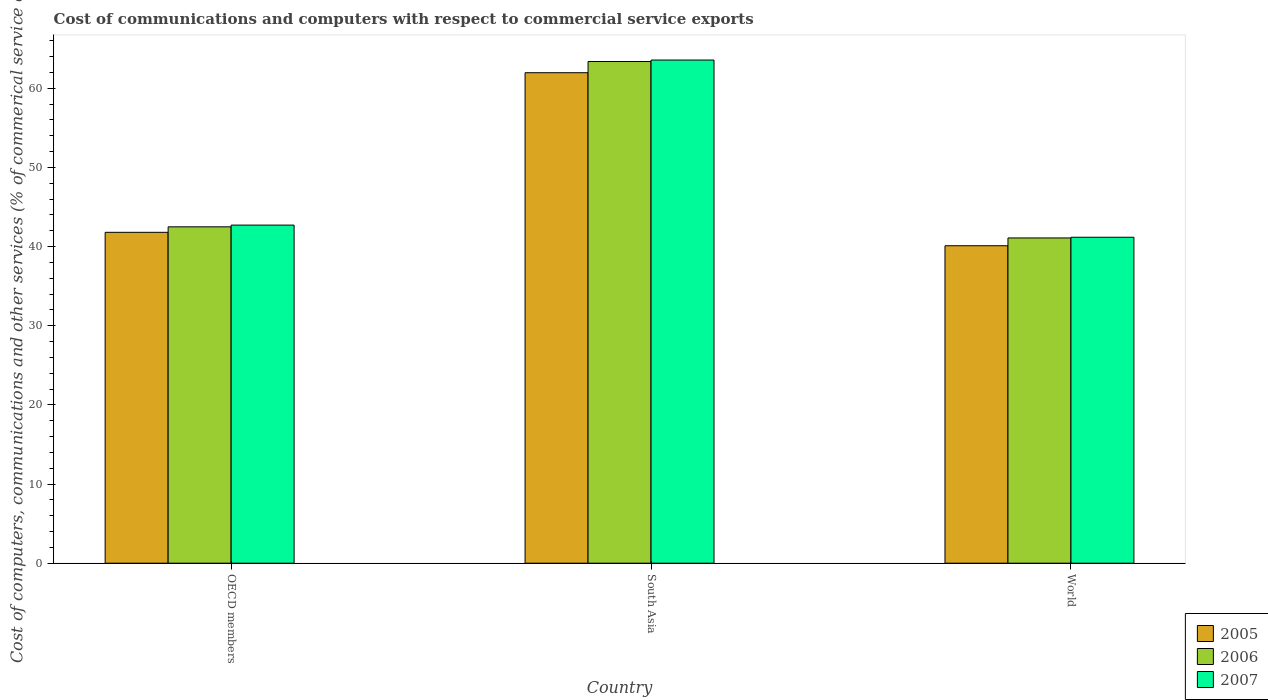How many different coloured bars are there?
Ensure brevity in your answer.  3. How many groups of bars are there?
Your answer should be very brief. 3. Are the number of bars per tick equal to the number of legend labels?
Offer a very short reply. Yes. Are the number of bars on each tick of the X-axis equal?
Give a very brief answer. Yes. What is the label of the 2nd group of bars from the left?
Provide a succinct answer. South Asia. What is the cost of communications and computers in 2006 in World?
Provide a succinct answer. 41.09. Across all countries, what is the maximum cost of communications and computers in 2006?
Provide a short and direct response. 63.38. Across all countries, what is the minimum cost of communications and computers in 2006?
Offer a terse response. 41.09. What is the total cost of communications and computers in 2006 in the graph?
Provide a short and direct response. 146.97. What is the difference between the cost of communications and computers in 2007 in OECD members and that in World?
Ensure brevity in your answer.  1.54. What is the difference between the cost of communications and computers in 2007 in OECD members and the cost of communications and computers in 2006 in South Asia?
Your answer should be compact. -20.67. What is the average cost of communications and computers in 2005 per country?
Ensure brevity in your answer.  47.96. What is the difference between the cost of communications and computers of/in 2006 and cost of communications and computers of/in 2007 in World?
Your answer should be compact. -0.09. What is the ratio of the cost of communications and computers in 2005 in OECD members to that in World?
Ensure brevity in your answer.  1.04. Is the cost of communications and computers in 2007 in OECD members less than that in South Asia?
Your answer should be very brief. Yes. Is the difference between the cost of communications and computers in 2006 in OECD members and World greater than the difference between the cost of communications and computers in 2007 in OECD members and World?
Offer a terse response. No. What is the difference between the highest and the second highest cost of communications and computers in 2005?
Offer a terse response. -1.7. What is the difference between the highest and the lowest cost of communications and computers in 2007?
Offer a terse response. 22.39. What does the 1st bar from the left in OECD members represents?
Offer a terse response. 2005. What does the 1st bar from the right in World represents?
Your response must be concise. 2007. Are all the bars in the graph horizontal?
Ensure brevity in your answer.  No. Does the graph contain any zero values?
Give a very brief answer. No. Where does the legend appear in the graph?
Offer a terse response. Bottom right. How many legend labels are there?
Your response must be concise. 3. What is the title of the graph?
Make the answer very short. Cost of communications and computers with respect to commercial service exports. What is the label or title of the X-axis?
Make the answer very short. Country. What is the label or title of the Y-axis?
Provide a short and direct response. Cost of computers, communications and other services (% of commerical service exports). What is the Cost of computers, communications and other services (% of commerical service exports) in 2005 in OECD members?
Your answer should be compact. 41.8. What is the Cost of computers, communications and other services (% of commerical service exports) of 2006 in OECD members?
Provide a short and direct response. 42.5. What is the Cost of computers, communications and other services (% of commerical service exports) of 2007 in OECD members?
Your response must be concise. 42.72. What is the Cost of computers, communications and other services (% of commerical service exports) in 2005 in South Asia?
Give a very brief answer. 61.97. What is the Cost of computers, communications and other services (% of commerical service exports) in 2006 in South Asia?
Ensure brevity in your answer.  63.38. What is the Cost of computers, communications and other services (% of commerical service exports) of 2007 in South Asia?
Provide a succinct answer. 63.57. What is the Cost of computers, communications and other services (% of commerical service exports) in 2005 in World?
Your answer should be compact. 40.11. What is the Cost of computers, communications and other services (% of commerical service exports) in 2006 in World?
Provide a short and direct response. 41.09. What is the Cost of computers, communications and other services (% of commerical service exports) in 2007 in World?
Make the answer very short. 41.18. Across all countries, what is the maximum Cost of computers, communications and other services (% of commerical service exports) in 2005?
Ensure brevity in your answer.  61.97. Across all countries, what is the maximum Cost of computers, communications and other services (% of commerical service exports) of 2006?
Your answer should be very brief. 63.38. Across all countries, what is the maximum Cost of computers, communications and other services (% of commerical service exports) in 2007?
Your answer should be very brief. 63.57. Across all countries, what is the minimum Cost of computers, communications and other services (% of commerical service exports) of 2005?
Your answer should be compact. 40.11. Across all countries, what is the minimum Cost of computers, communications and other services (% of commerical service exports) in 2006?
Offer a very short reply. 41.09. Across all countries, what is the minimum Cost of computers, communications and other services (% of commerical service exports) of 2007?
Give a very brief answer. 41.18. What is the total Cost of computers, communications and other services (% of commerical service exports) of 2005 in the graph?
Your answer should be compact. 143.88. What is the total Cost of computers, communications and other services (% of commerical service exports) of 2006 in the graph?
Your answer should be very brief. 146.97. What is the total Cost of computers, communications and other services (% of commerical service exports) in 2007 in the graph?
Offer a terse response. 147.46. What is the difference between the Cost of computers, communications and other services (% of commerical service exports) in 2005 in OECD members and that in South Asia?
Your response must be concise. -20.16. What is the difference between the Cost of computers, communications and other services (% of commerical service exports) of 2006 in OECD members and that in South Asia?
Offer a very short reply. -20.88. What is the difference between the Cost of computers, communications and other services (% of commerical service exports) in 2007 in OECD members and that in South Asia?
Keep it short and to the point. -20.85. What is the difference between the Cost of computers, communications and other services (% of commerical service exports) of 2005 in OECD members and that in World?
Provide a succinct answer. 1.7. What is the difference between the Cost of computers, communications and other services (% of commerical service exports) of 2006 in OECD members and that in World?
Provide a succinct answer. 1.4. What is the difference between the Cost of computers, communications and other services (% of commerical service exports) in 2007 in OECD members and that in World?
Keep it short and to the point. 1.54. What is the difference between the Cost of computers, communications and other services (% of commerical service exports) in 2005 in South Asia and that in World?
Provide a succinct answer. 21.86. What is the difference between the Cost of computers, communications and other services (% of commerical service exports) in 2006 in South Asia and that in World?
Ensure brevity in your answer.  22.29. What is the difference between the Cost of computers, communications and other services (% of commerical service exports) in 2007 in South Asia and that in World?
Your answer should be compact. 22.39. What is the difference between the Cost of computers, communications and other services (% of commerical service exports) of 2005 in OECD members and the Cost of computers, communications and other services (% of commerical service exports) of 2006 in South Asia?
Offer a terse response. -21.58. What is the difference between the Cost of computers, communications and other services (% of commerical service exports) in 2005 in OECD members and the Cost of computers, communications and other services (% of commerical service exports) in 2007 in South Asia?
Offer a terse response. -21.77. What is the difference between the Cost of computers, communications and other services (% of commerical service exports) in 2006 in OECD members and the Cost of computers, communications and other services (% of commerical service exports) in 2007 in South Asia?
Make the answer very short. -21.07. What is the difference between the Cost of computers, communications and other services (% of commerical service exports) in 2005 in OECD members and the Cost of computers, communications and other services (% of commerical service exports) in 2006 in World?
Your response must be concise. 0.71. What is the difference between the Cost of computers, communications and other services (% of commerical service exports) of 2005 in OECD members and the Cost of computers, communications and other services (% of commerical service exports) of 2007 in World?
Keep it short and to the point. 0.62. What is the difference between the Cost of computers, communications and other services (% of commerical service exports) in 2006 in OECD members and the Cost of computers, communications and other services (% of commerical service exports) in 2007 in World?
Provide a succinct answer. 1.32. What is the difference between the Cost of computers, communications and other services (% of commerical service exports) in 2005 in South Asia and the Cost of computers, communications and other services (% of commerical service exports) in 2006 in World?
Your response must be concise. 20.88. What is the difference between the Cost of computers, communications and other services (% of commerical service exports) in 2005 in South Asia and the Cost of computers, communications and other services (% of commerical service exports) in 2007 in World?
Provide a short and direct response. 20.79. What is the difference between the Cost of computers, communications and other services (% of commerical service exports) in 2006 in South Asia and the Cost of computers, communications and other services (% of commerical service exports) in 2007 in World?
Provide a short and direct response. 22.2. What is the average Cost of computers, communications and other services (% of commerical service exports) of 2005 per country?
Your answer should be very brief. 47.96. What is the average Cost of computers, communications and other services (% of commerical service exports) in 2006 per country?
Your answer should be very brief. 48.99. What is the average Cost of computers, communications and other services (% of commerical service exports) in 2007 per country?
Give a very brief answer. 49.15. What is the difference between the Cost of computers, communications and other services (% of commerical service exports) in 2005 and Cost of computers, communications and other services (% of commerical service exports) in 2006 in OECD members?
Provide a short and direct response. -0.69. What is the difference between the Cost of computers, communications and other services (% of commerical service exports) in 2005 and Cost of computers, communications and other services (% of commerical service exports) in 2007 in OECD members?
Provide a succinct answer. -0.91. What is the difference between the Cost of computers, communications and other services (% of commerical service exports) in 2006 and Cost of computers, communications and other services (% of commerical service exports) in 2007 in OECD members?
Ensure brevity in your answer.  -0.22. What is the difference between the Cost of computers, communications and other services (% of commerical service exports) of 2005 and Cost of computers, communications and other services (% of commerical service exports) of 2006 in South Asia?
Offer a very short reply. -1.41. What is the difference between the Cost of computers, communications and other services (% of commerical service exports) in 2005 and Cost of computers, communications and other services (% of commerical service exports) in 2007 in South Asia?
Your answer should be very brief. -1.6. What is the difference between the Cost of computers, communications and other services (% of commerical service exports) in 2006 and Cost of computers, communications and other services (% of commerical service exports) in 2007 in South Asia?
Keep it short and to the point. -0.19. What is the difference between the Cost of computers, communications and other services (% of commerical service exports) of 2005 and Cost of computers, communications and other services (% of commerical service exports) of 2006 in World?
Make the answer very short. -0.98. What is the difference between the Cost of computers, communications and other services (% of commerical service exports) in 2005 and Cost of computers, communications and other services (% of commerical service exports) in 2007 in World?
Offer a very short reply. -1.07. What is the difference between the Cost of computers, communications and other services (% of commerical service exports) of 2006 and Cost of computers, communications and other services (% of commerical service exports) of 2007 in World?
Offer a terse response. -0.09. What is the ratio of the Cost of computers, communications and other services (% of commerical service exports) of 2005 in OECD members to that in South Asia?
Offer a terse response. 0.67. What is the ratio of the Cost of computers, communications and other services (% of commerical service exports) of 2006 in OECD members to that in South Asia?
Make the answer very short. 0.67. What is the ratio of the Cost of computers, communications and other services (% of commerical service exports) of 2007 in OECD members to that in South Asia?
Keep it short and to the point. 0.67. What is the ratio of the Cost of computers, communications and other services (% of commerical service exports) in 2005 in OECD members to that in World?
Provide a short and direct response. 1.04. What is the ratio of the Cost of computers, communications and other services (% of commerical service exports) in 2006 in OECD members to that in World?
Keep it short and to the point. 1.03. What is the ratio of the Cost of computers, communications and other services (% of commerical service exports) in 2007 in OECD members to that in World?
Your answer should be compact. 1.04. What is the ratio of the Cost of computers, communications and other services (% of commerical service exports) of 2005 in South Asia to that in World?
Keep it short and to the point. 1.54. What is the ratio of the Cost of computers, communications and other services (% of commerical service exports) of 2006 in South Asia to that in World?
Offer a terse response. 1.54. What is the ratio of the Cost of computers, communications and other services (% of commerical service exports) of 2007 in South Asia to that in World?
Give a very brief answer. 1.54. What is the difference between the highest and the second highest Cost of computers, communications and other services (% of commerical service exports) in 2005?
Offer a very short reply. 20.16. What is the difference between the highest and the second highest Cost of computers, communications and other services (% of commerical service exports) in 2006?
Your answer should be very brief. 20.88. What is the difference between the highest and the second highest Cost of computers, communications and other services (% of commerical service exports) of 2007?
Provide a succinct answer. 20.85. What is the difference between the highest and the lowest Cost of computers, communications and other services (% of commerical service exports) of 2005?
Offer a terse response. 21.86. What is the difference between the highest and the lowest Cost of computers, communications and other services (% of commerical service exports) in 2006?
Provide a short and direct response. 22.29. What is the difference between the highest and the lowest Cost of computers, communications and other services (% of commerical service exports) of 2007?
Provide a short and direct response. 22.39. 